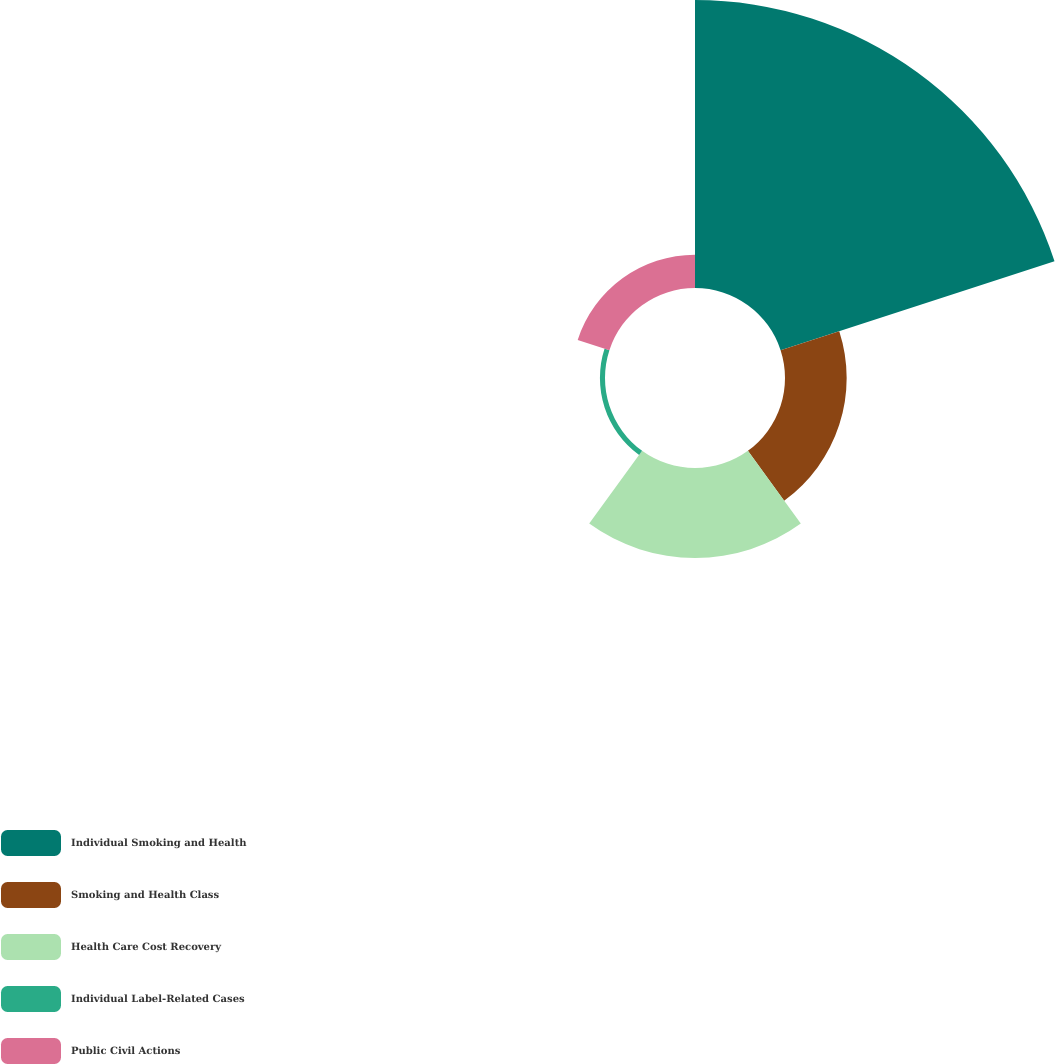Convert chart. <chart><loc_0><loc_0><loc_500><loc_500><pie_chart><fcel>Individual Smoking and Health<fcel>Smoking and Health Class<fcel>Health Care Cost Recovery<fcel>Individual Label-Related Cases<fcel>Public Civil Actions<nl><fcel>60.25%<fcel>12.9%<fcel>18.82%<fcel>1.06%<fcel>6.98%<nl></chart> 